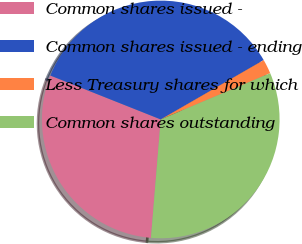<chart> <loc_0><loc_0><loc_500><loc_500><pie_chart><fcel>Common shares issued -<fcel>Common shares issued - ending<fcel>Less Treasury shares for which<fcel>Common shares outstanding<nl><fcel>29.71%<fcel>35.65%<fcel>1.96%<fcel>32.68%<nl></chart> 